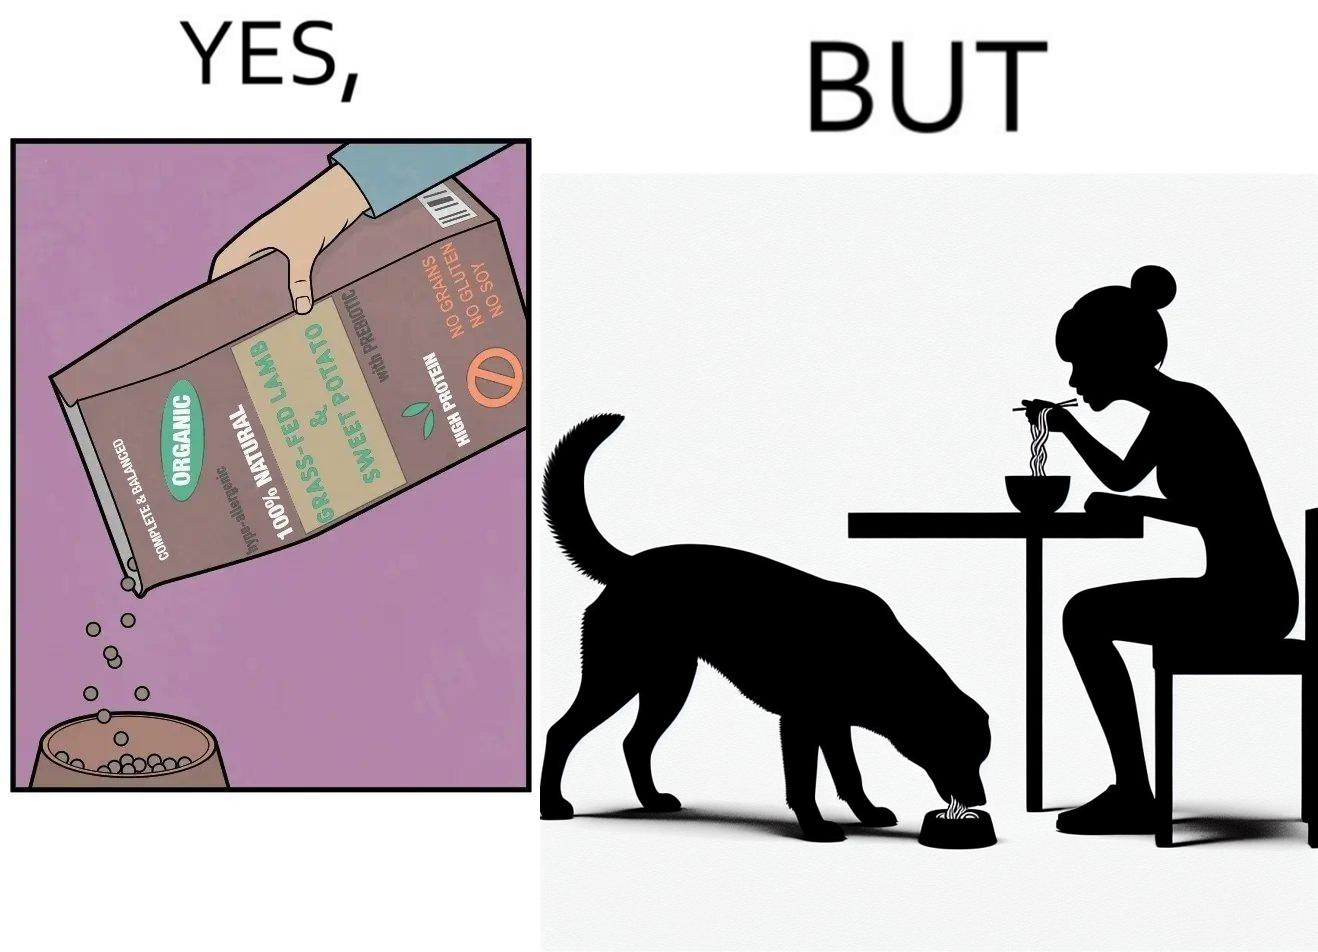Explain the humor or irony in this image. The image is funny because while the food for the dog that the woman pours is well balanced, the food that she herself is eating is bad for her health. 